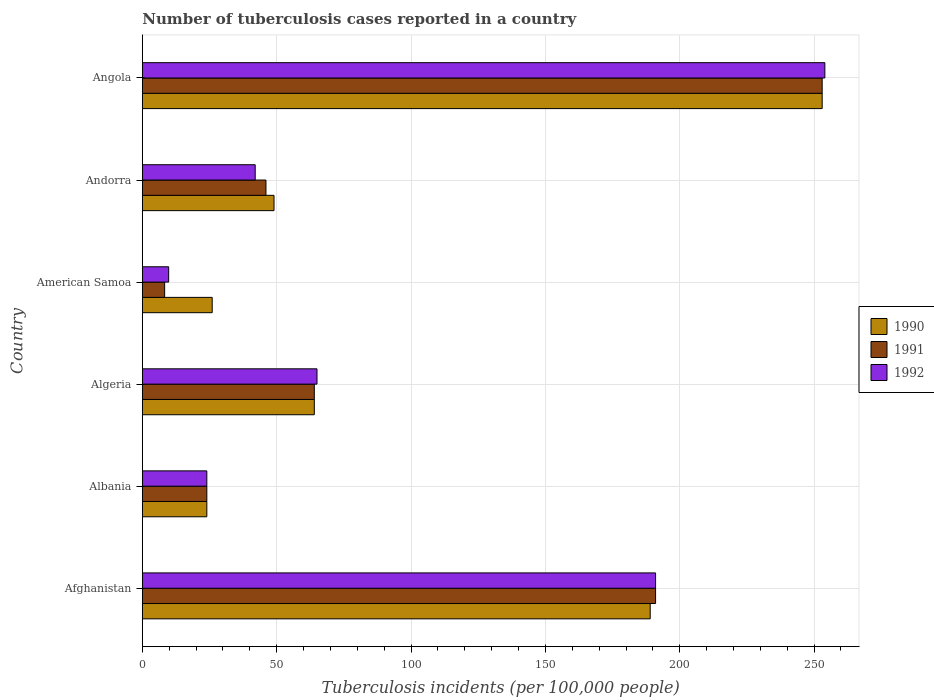How many different coloured bars are there?
Make the answer very short. 3. How many groups of bars are there?
Give a very brief answer. 6. Are the number of bars per tick equal to the number of legend labels?
Your answer should be compact. Yes. Are the number of bars on each tick of the Y-axis equal?
Keep it short and to the point. Yes. How many bars are there on the 2nd tick from the bottom?
Provide a succinct answer. 3. What is the label of the 5th group of bars from the top?
Keep it short and to the point. Albania. In how many cases, is the number of bars for a given country not equal to the number of legend labels?
Give a very brief answer. 0. What is the number of tuberculosis cases reported in in 1992 in Angola?
Give a very brief answer. 254. Across all countries, what is the maximum number of tuberculosis cases reported in in 1990?
Keep it short and to the point. 253. In which country was the number of tuberculosis cases reported in in 1990 maximum?
Ensure brevity in your answer.  Angola. In which country was the number of tuberculosis cases reported in in 1991 minimum?
Give a very brief answer. American Samoa. What is the total number of tuberculosis cases reported in in 1992 in the graph?
Offer a terse response. 585.8. What is the difference between the number of tuberculosis cases reported in in 1990 in Albania and the number of tuberculosis cases reported in in 1992 in Afghanistan?
Provide a short and direct response. -167. What is the average number of tuberculosis cases reported in in 1992 per country?
Make the answer very short. 97.63. What is the difference between the number of tuberculosis cases reported in in 1990 and number of tuberculosis cases reported in in 1992 in American Samoa?
Make the answer very short. 16.2. In how many countries, is the number of tuberculosis cases reported in in 1991 greater than 80 ?
Your answer should be very brief. 2. What is the ratio of the number of tuberculosis cases reported in in 1992 in Afghanistan to that in Albania?
Provide a short and direct response. 7.96. What is the difference between the highest and the lowest number of tuberculosis cases reported in in 1992?
Your response must be concise. 244.2. Is it the case that in every country, the sum of the number of tuberculosis cases reported in in 1992 and number of tuberculosis cases reported in in 1991 is greater than the number of tuberculosis cases reported in in 1990?
Your response must be concise. No. How many bars are there?
Ensure brevity in your answer.  18. How many countries are there in the graph?
Keep it short and to the point. 6. What is the difference between two consecutive major ticks on the X-axis?
Provide a succinct answer. 50. Where does the legend appear in the graph?
Give a very brief answer. Center right. What is the title of the graph?
Offer a terse response. Number of tuberculosis cases reported in a country. What is the label or title of the X-axis?
Your answer should be compact. Tuberculosis incidents (per 100,0 people). What is the Tuberculosis incidents (per 100,000 people) in 1990 in Afghanistan?
Ensure brevity in your answer.  189. What is the Tuberculosis incidents (per 100,000 people) of 1991 in Afghanistan?
Provide a short and direct response. 191. What is the Tuberculosis incidents (per 100,000 people) in 1992 in Afghanistan?
Offer a terse response. 191. What is the Tuberculosis incidents (per 100,000 people) in 1990 in Albania?
Your answer should be compact. 24. What is the Tuberculosis incidents (per 100,000 people) of 1991 in Albania?
Your response must be concise. 24. What is the Tuberculosis incidents (per 100,000 people) in 1992 in Algeria?
Your response must be concise. 65. What is the Tuberculosis incidents (per 100,000 people) in 1991 in Andorra?
Make the answer very short. 46. What is the Tuberculosis incidents (per 100,000 people) of 1992 in Andorra?
Keep it short and to the point. 42. What is the Tuberculosis incidents (per 100,000 people) in 1990 in Angola?
Offer a very short reply. 253. What is the Tuberculosis incidents (per 100,000 people) in 1991 in Angola?
Provide a succinct answer. 253. What is the Tuberculosis incidents (per 100,000 people) of 1992 in Angola?
Your answer should be very brief. 254. Across all countries, what is the maximum Tuberculosis incidents (per 100,000 people) in 1990?
Provide a succinct answer. 253. Across all countries, what is the maximum Tuberculosis incidents (per 100,000 people) in 1991?
Give a very brief answer. 253. Across all countries, what is the maximum Tuberculosis incidents (per 100,000 people) in 1992?
Offer a very short reply. 254. Across all countries, what is the minimum Tuberculosis incidents (per 100,000 people) of 1991?
Provide a succinct answer. 8.3. Across all countries, what is the minimum Tuberculosis incidents (per 100,000 people) of 1992?
Ensure brevity in your answer.  9.8. What is the total Tuberculosis incidents (per 100,000 people) in 1990 in the graph?
Your answer should be very brief. 605. What is the total Tuberculosis incidents (per 100,000 people) of 1991 in the graph?
Your response must be concise. 586.3. What is the total Tuberculosis incidents (per 100,000 people) of 1992 in the graph?
Provide a short and direct response. 585.8. What is the difference between the Tuberculosis incidents (per 100,000 people) of 1990 in Afghanistan and that in Albania?
Provide a short and direct response. 165. What is the difference between the Tuberculosis incidents (per 100,000 people) of 1991 in Afghanistan and that in Albania?
Give a very brief answer. 167. What is the difference between the Tuberculosis incidents (per 100,000 people) in 1992 in Afghanistan and that in Albania?
Offer a very short reply. 167. What is the difference between the Tuberculosis incidents (per 100,000 people) in 1990 in Afghanistan and that in Algeria?
Make the answer very short. 125. What is the difference between the Tuberculosis incidents (per 100,000 people) of 1991 in Afghanistan and that in Algeria?
Give a very brief answer. 127. What is the difference between the Tuberculosis incidents (per 100,000 people) in 1992 in Afghanistan and that in Algeria?
Your answer should be very brief. 126. What is the difference between the Tuberculosis incidents (per 100,000 people) of 1990 in Afghanistan and that in American Samoa?
Your answer should be very brief. 163. What is the difference between the Tuberculosis incidents (per 100,000 people) in 1991 in Afghanistan and that in American Samoa?
Provide a succinct answer. 182.7. What is the difference between the Tuberculosis incidents (per 100,000 people) of 1992 in Afghanistan and that in American Samoa?
Keep it short and to the point. 181.2. What is the difference between the Tuberculosis incidents (per 100,000 people) in 1990 in Afghanistan and that in Andorra?
Keep it short and to the point. 140. What is the difference between the Tuberculosis incidents (per 100,000 people) of 1991 in Afghanistan and that in Andorra?
Offer a very short reply. 145. What is the difference between the Tuberculosis incidents (per 100,000 people) of 1992 in Afghanistan and that in Andorra?
Your answer should be compact. 149. What is the difference between the Tuberculosis incidents (per 100,000 people) in 1990 in Afghanistan and that in Angola?
Your answer should be compact. -64. What is the difference between the Tuberculosis incidents (per 100,000 people) in 1991 in Afghanistan and that in Angola?
Keep it short and to the point. -62. What is the difference between the Tuberculosis incidents (per 100,000 people) of 1992 in Afghanistan and that in Angola?
Keep it short and to the point. -63. What is the difference between the Tuberculosis incidents (per 100,000 people) in 1992 in Albania and that in Algeria?
Your answer should be very brief. -41. What is the difference between the Tuberculosis incidents (per 100,000 people) in 1991 in Albania and that in American Samoa?
Offer a very short reply. 15.7. What is the difference between the Tuberculosis incidents (per 100,000 people) of 1992 in Albania and that in American Samoa?
Your answer should be very brief. 14.2. What is the difference between the Tuberculosis incidents (per 100,000 people) in 1990 in Albania and that in Andorra?
Give a very brief answer. -25. What is the difference between the Tuberculosis incidents (per 100,000 people) of 1992 in Albania and that in Andorra?
Your answer should be very brief. -18. What is the difference between the Tuberculosis incidents (per 100,000 people) in 1990 in Albania and that in Angola?
Your answer should be very brief. -229. What is the difference between the Tuberculosis incidents (per 100,000 people) in 1991 in Albania and that in Angola?
Your answer should be very brief. -229. What is the difference between the Tuberculosis incidents (per 100,000 people) of 1992 in Albania and that in Angola?
Your response must be concise. -230. What is the difference between the Tuberculosis incidents (per 100,000 people) of 1990 in Algeria and that in American Samoa?
Offer a very short reply. 38. What is the difference between the Tuberculosis incidents (per 100,000 people) in 1991 in Algeria and that in American Samoa?
Keep it short and to the point. 55.7. What is the difference between the Tuberculosis incidents (per 100,000 people) in 1992 in Algeria and that in American Samoa?
Give a very brief answer. 55.2. What is the difference between the Tuberculosis incidents (per 100,000 people) in 1991 in Algeria and that in Andorra?
Provide a succinct answer. 18. What is the difference between the Tuberculosis incidents (per 100,000 people) of 1990 in Algeria and that in Angola?
Your answer should be very brief. -189. What is the difference between the Tuberculosis incidents (per 100,000 people) of 1991 in Algeria and that in Angola?
Keep it short and to the point. -189. What is the difference between the Tuberculosis incidents (per 100,000 people) of 1992 in Algeria and that in Angola?
Keep it short and to the point. -189. What is the difference between the Tuberculosis incidents (per 100,000 people) of 1991 in American Samoa and that in Andorra?
Ensure brevity in your answer.  -37.7. What is the difference between the Tuberculosis incidents (per 100,000 people) of 1992 in American Samoa and that in Andorra?
Your answer should be very brief. -32.2. What is the difference between the Tuberculosis incidents (per 100,000 people) in 1990 in American Samoa and that in Angola?
Ensure brevity in your answer.  -227. What is the difference between the Tuberculosis incidents (per 100,000 people) of 1991 in American Samoa and that in Angola?
Give a very brief answer. -244.7. What is the difference between the Tuberculosis incidents (per 100,000 people) of 1992 in American Samoa and that in Angola?
Make the answer very short. -244.2. What is the difference between the Tuberculosis incidents (per 100,000 people) of 1990 in Andorra and that in Angola?
Your answer should be compact. -204. What is the difference between the Tuberculosis incidents (per 100,000 people) in 1991 in Andorra and that in Angola?
Ensure brevity in your answer.  -207. What is the difference between the Tuberculosis incidents (per 100,000 people) of 1992 in Andorra and that in Angola?
Ensure brevity in your answer.  -212. What is the difference between the Tuberculosis incidents (per 100,000 people) of 1990 in Afghanistan and the Tuberculosis incidents (per 100,000 people) of 1991 in Albania?
Provide a short and direct response. 165. What is the difference between the Tuberculosis incidents (per 100,000 people) of 1990 in Afghanistan and the Tuberculosis incidents (per 100,000 people) of 1992 in Albania?
Provide a short and direct response. 165. What is the difference between the Tuberculosis incidents (per 100,000 people) of 1991 in Afghanistan and the Tuberculosis incidents (per 100,000 people) of 1992 in Albania?
Your answer should be very brief. 167. What is the difference between the Tuberculosis incidents (per 100,000 people) in 1990 in Afghanistan and the Tuberculosis incidents (per 100,000 people) in 1991 in Algeria?
Ensure brevity in your answer.  125. What is the difference between the Tuberculosis incidents (per 100,000 people) of 1990 in Afghanistan and the Tuberculosis incidents (per 100,000 people) of 1992 in Algeria?
Provide a succinct answer. 124. What is the difference between the Tuberculosis incidents (per 100,000 people) in 1991 in Afghanistan and the Tuberculosis incidents (per 100,000 people) in 1992 in Algeria?
Your answer should be compact. 126. What is the difference between the Tuberculosis incidents (per 100,000 people) of 1990 in Afghanistan and the Tuberculosis incidents (per 100,000 people) of 1991 in American Samoa?
Keep it short and to the point. 180.7. What is the difference between the Tuberculosis incidents (per 100,000 people) in 1990 in Afghanistan and the Tuberculosis incidents (per 100,000 people) in 1992 in American Samoa?
Your answer should be compact. 179.2. What is the difference between the Tuberculosis incidents (per 100,000 people) of 1991 in Afghanistan and the Tuberculosis incidents (per 100,000 people) of 1992 in American Samoa?
Offer a very short reply. 181.2. What is the difference between the Tuberculosis incidents (per 100,000 people) in 1990 in Afghanistan and the Tuberculosis incidents (per 100,000 people) in 1991 in Andorra?
Make the answer very short. 143. What is the difference between the Tuberculosis incidents (per 100,000 people) of 1990 in Afghanistan and the Tuberculosis incidents (per 100,000 people) of 1992 in Andorra?
Your response must be concise. 147. What is the difference between the Tuberculosis incidents (per 100,000 people) in 1991 in Afghanistan and the Tuberculosis incidents (per 100,000 people) in 1992 in Andorra?
Ensure brevity in your answer.  149. What is the difference between the Tuberculosis incidents (per 100,000 people) in 1990 in Afghanistan and the Tuberculosis incidents (per 100,000 people) in 1991 in Angola?
Provide a short and direct response. -64. What is the difference between the Tuberculosis incidents (per 100,000 people) of 1990 in Afghanistan and the Tuberculosis incidents (per 100,000 people) of 1992 in Angola?
Keep it short and to the point. -65. What is the difference between the Tuberculosis incidents (per 100,000 people) of 1991 in Afghanistan and the Tuberculosis incidents (per 100,000 people) of 1992 in Angola?
Provide a succinct answer. -63. What is the difference between the Tuberculosis incidents (per 100,000 people) in 1990 in Albania and the Tuberculosis incidents (per 100,000 people) in 1992 in Algeria?
Keep it short and to the point. -41. What is the difference between the Tuberculosis incidents (per 100,000 people) in 1991 in Albania and the Tuberculosis incidents (per 100,000 people) in 1992 in Algeria?
Keep it short and to the point. -41. What is the difference between the Tuberculosis incidents (per 100,000 people) of 1990 in Albania and the Tuberculosis incidents (per 100,000 people) of 1991 in American Samoa?
Your answer should be compact. 15.7. What is the difference between the Tuberculosis incidents (per 100,000 people) in 1990 in Albania and the Tuberculosis incidents (per 100,000 people) in 1992 in American Samoa?
Offer a terse response. 14.2. What is the difference between the Tuberculosis incidents (per 100,000 people) in 1991 in Albania and the Tuberculosis incidents (per 100,000 people) in 1992 in American Samoa?
Provide a succinct answer. 14.2. What is the difference between the Tuberculosis incidents (per 100,000 people) of 1990 in Albania and the Tuberculosis incidents (per 100,000 people) of 1991 in Andorra?
Your answer should be compact. -22. What is the difference between the Tuberculosis incidents (per 100,000 people) in 1990 in Albania and the Tuberculosis incidents (per 100,000 people) in 1992 in Andorra?
Ensure brevity in your answer.  -18. What is the difference between the Tuberculosis incidents (per 100,000 people) of 1990 in Albania and the Tuberculosis incidents (per 100,000 people) of 1991 in Angola?
Ensure brevity in your answer.  -229. What is the difference between the Tuberculosis incidents (per 100,000 people) of 1990 in Albania and the Tuberculosis incidents (per 100,000 people) of 1992 in Angola?
Offer a very short reply. -230. What is the difference between the Tuberculosis incidents (per 100,000 people) in 1991 in Albania and the Tuberculosis incidents (per 100,000 people) in 1992 in Angola?
Provide a short and direct response. -230. What is the difference between the Tuberculosis incidents (per 100,000 people) of 1990 in Algeria and the Tuberculosis incidents (per 100,000 people) of 1991 in American Samoa?
Give a very brief answer. 55.7. What is the difference between the Tuberculosis incidents (per 100,000 people) in 1990 in Algeria and the Tuberculosis incidents (per 100,000 people) in 1992 in American Samoa?
Your response must be concise. 54.2. What is the difference between the Tuberculosis incidents (per 100,000 people) in 1991 in Algeria and the Tuberculosis incidents (per 100,000 people) in 1992 in American Samoa?
Give a very brief answer. 54.2. What is the difference between the Tuberculosis incidents (per 100,000 people) of 1990 in Algeria and the Tuberculosis incidents (per 100,000 people) of 1992 in Andorra?
Provide a short and direct response. 22. What is the difference between the Tuberculosis incidents (per 100,000 people) in 1991 in Algeria and the Tuberculosis incidents (per 100,000 people) in 1992 in Andorra?
Provide a succinct answer. 22. What is the difference between the Tuberculosis incidents (per 100,000 people) in 1990 in Algeria and the Tuberculosis incidents (per 100,000 people) in 1991 in Angola?
Ensure brevity in your answer.  -189. What is the difference between the Tuberculosis incidents (per 100,000 people) of 1990 in Algeria and the Tuberculosis incidents (per 100,000 people) of 1992 in Angola?
Your response must be concise. -190. What is the difference between the Tuberculosis incidents (per 100,000 people) in 1991 in Algeria and the Tuberculosis incidents (per 100,000 people) in 1992 in Angola?
Ensure brevity in your answer.  -190. What is the difference between the Tuberculosis incidents (per 100,000 people) of 1991 in American Samoa and the Tuberculosis incidents (per 100,000 people) of 1992 in Andorra?
Offer a very short reply. -33.7. What is the difference between the Tuberculosis incidents (per 100,000 people) of 1990 in American Samoa and the Tuberculosis incidents (per 100,000 people) of 1991 in Angola?
Your answer should be compact. -227. What is the difference between the Tuberculosis incidents (per 100,000 people) in 1990 in American Samoa and the Tuberculosis incidents (per 100,000 people) in 1992 in Angola?
Offer a very short reply. -228. What is the difference between the Tuberculosis incidents (per 100,000 people) in 1991 in American Samoa and the Tuberculosis incidents (per 100,000 people) in 1992 in Angola?
Your answer should be very brief. -245.7. What is the difference between the Tuberculosis incidents (per 100,000 people) in 1990 in Andorra and the Tuberculosis incidents (per 100,000 people) in 1991 in Angola?
Keep it short and to the point. -204. What is the difference between the Tuberculosis incidents (per 100,000 people) of 1990 in Andorra and the Tuberculosis incidents (per 100,000 people) of 1992 in Angola?
Your answer should be very brief. -205. What is the difference between the Tuberculosis incidents (per 100,000 people) of 1991 in Andorra and the Tuberculosis incidents (per 100,000 people) of 1992 in Angola?
Your response must be concise. -208. What is the average Tuberculosis incidents (per 100,000 people) of 1990 per country?
Make the answer very short. 100.83. What is the average Tuberculosis incidents (per 100,000 people) of 1991 per country?
Make the answer very short. 97.72. What is the average Tuberculosis incidents (per 100,000 people) in 1992 per country?
Provide a short and direct response. 97.63. What is the difference between the Tuberculosis incidents (per 100,000 people) of 1990 and Tuberculosis incidents (per 100,000 people) of 1992 in Afghanistan?
Give a very brief answer. -2. What is the difference between the Tuberculosis incidents (per 100,000 people) of 1990 and Tuberculosis incidents (per 100,000 people) of 1991 in Albania?
Your answer should be very brief. 0. What is the difference between the Tuberculosis incidents (per 100,000 people) in 1990 and Tuberculosis incidents (per 100,000 people) in 1992 in Albania?
Keep it short and to the point. 0. What is the difference between the Tuberculosis incidents (per 100,000 people) in 1990 and Tuberculosis incidents (per 100,000 people) in 1992 in Algeria?
Your answer should be compact. -1. What is the difference between the Tuberculosis incidents (per 100,000 people) in 1990 and Tuberculosis incidents (per 100,000 people) in 1991 in American Samoa?
Make the answer very short. 17.7. What is the difference between the Tuberculosis incidents (per 100,000 people) in 1991 and Tuberculosis incidents (per 100,000 people) in 1992 in American Samoa?
Keep it short and to the point. -1.5. What is the ratio of the Tuberculosis incidents (per 100,000 people) of 1990 in Afghanistan to that in Albania?
Offer a very short reply. 7.88. What is the ratio of the Tuberculosis incidents (per 100,000 people) of 1991 in Afghanistan to that in Albania?
Your answer should be very brief. 7.96. What is the ratio of the Tuberculosis incidents (per 100,000 people) in 1992 in Afghanistan to that in Albania?
Provide a short and direct response. 7.96. What is the ratio of the Tuberculosis incidents (per 100,000 people) in 1990 in Afghanistan to that in Algeria?
Ensure brevity in your answer.  2.95. What is the ratio of the Tuberculosis incidents (per 100,000 people) in 1991 in Afghanistan to that in Algeria?
Offer a very short reply. 2.98. What is the ratio of the Tuberculosis incidents (per 100,000 people) in 1992 in Afghanistan to that in Algeria?
Your answer should be compact. 2.94. What is the ratio of the Tuberculosis incidents (per 100,000 people) in 1990 in Afghanistan to that in American Samoa?
Provide a short and direct response. 7.27. What is the ratio of the Tuberculosis incidents (per 100,000 people) in 1991 in Afghanistan to that in American Samoa?
Offer a terse response. 23.01. What is the ratio of the Tuberculosis incidents (per 100,000 people) of 1992 in Afghanistan to that in American Samoa?
Your answer should be very brief. 19.49. What is the ratio of the Tuberculosis incidents (per 100,000 people) in 1990 in Afghanistan to that in Andorra?
Keep it short and to the point. 3.86. What is the ratio of the Tuberculosis incidents (per 100,000 people) of 1991 in Afghanistan to that in Andorra?
Your answer should be compact. 4.15. What is the ratio of the Tuberculosis incidents (per 100,000 people) of 1992 in Afghanistan to that in Andorra?
Ensure brevity in your answer.  4.55. What is the ratio of the Tuberculosis incidents (per 100,000 people) in 1990 in Afghanistan to that in Angola?
Make the answer very short. 0.75. What is the ratio of the Tuberculosis incidents (per 100,000 people) in 1991 in Afghanistan to that in Angola?
Provide a succinct answer. 0.75. What is the ratio of the Tuberculosis incidents (per 100,000 people) of 1992 in Afghanistan to that in Angola?
Your answer should be compact. 0.75. What is the ratio of the Tuberculosis incidents (per 100,000 people) of 1992 in Albania to that in Algeria?
Provide a succinct answer. 0.37. What is the ratio of the Tuberculosis incidents (per 100,000 people) of 1991 in Albania to that in American Samoa?
Give a very brief answer. 2.89. What is the ratio of the Tuberculosis incidents (per 100,000 people) in 1992 in Albania to that in American Samoa?
Provide a short and direct response. 2.45. What is the ratio of the Tuberculosis incidents (per 100,000 people) of 1990 in Albania to that in Andorra?
Make the answer very short. 0.49. What is the ratio of the Tuberculosis incidents (per 100,000 people) of 1991 in Albania to that in Andorra?
Offer a very short reply. 0.52. What is the ratio of the Tuberculosis incidents (per 100,000 people) in 1990 in Albania to that in Angola?
Your answer should be very brief. 0.09. What is the ratio of the Tuberculosis incidents (per 100,000 people) in 1991 in Albania to that in Angola?
Give a very brief answer. 0.09. What is the ratio of the Tuberculosis incidents (per 100,000 people) in 1992 in Albania to that in Angola?
Offer a very short reply. 0.09. What is the ratio of the Tuberculosis incidents (per 100,000 people) in 1990 in Algeria to that in American Samoa?
Make the answer very short. 2.46. What is the ratio of the Tuberculosis incidents (per 100,000 people) of 1991 in Algeria to that in American Samoa?
Offer a very short reply. 7.71. What is the ratio of the Tuberculosis incidents (per 100,000 people) of 1992 in Algeria to that in American Samoa?
Ensure brevity in your answer.  6.63. What is the ratio of the Tuberculosis incidents (per 100,000 people) of 1990 in Algeria to that in Andorra?
Ensure brevity in your answer.  1.31. What is the ratio of the Tuberculosis incidents (per 100,000 people) in 1991 in Algeria to that in Andorra?
Your answer should be very brief. 1.39. What is the ratio of the Tuberculosis incidents (per 100,000 people) in 1992 in Algeria to that in Andorra?
Give a very brief answer. 1.55. What is the ratio of the Tuberculosis incidents (per 100,000 people) of 1990 in Algeria to that in Angola?
Offer a very short reply. 0.25. What is the ratio of the Tuberculosis incidents (per 100,000 people) in 1991 in Algeria to that in Angola?
Provide a succinct answer. 0.25. What is the ratio of the Tuberculosis incidents (per 100,000 people) in 1992 in Algeria to that in Angola?
Ensure brevity in your answer.  0.26. What is the ratio of the Tuberculosis incidents (per 100,000 people) of 1990 in American Samoa to that in Andorra?
Make the answer very short. 0.53. What is the ratio of the Tuberculosis incidents (per 100,000 people) in 1991 in American Samoa to that in Andorra?
Give a very brief answer. 0.18. What is the ratio of the Tuberculosis incidents (per 100,000 people) of 1992 in American Samoa to that in Andorra?
Provide a short and direct response. 0.23. What is the ratio of the Tuberculosis incidents (per 100,000 people) of 1990 in American Samoa to that in Angola?
Keep it short and to the point. 0.1. What is the ratio of the Tuberculosis incidents (per 100,000 people) in 1991 in American Samoa to that in Angola?
Make the answer very short. 0.03. What is the ratio of the Tuberculosis incidents (per 100,000 people) of 1992 in American Samoa to that in Angola?
Provide a succinct answer. 0.04. What is the ratio of the Tuberculosis incidents (per 100,000 people) of 1990 in Andorra to that in Angola?
Ensure brevity in your answer.  0.19. What is the ratio of the Tuberculosis incidents (per 100,000 people) of 1991 in Andorra to that in Angola?
Your response must be concise. 0.18. What is the ratio of the Tuberculosis incidents (per 100,000 people) of 1992 in Andorra to that in Angola?
Provide a succinct answer. 0.17. What is the difference between the highest and the second highest Tuberculosis incidents (per 100,000 people) of 1992?
Your response must be concise. 63. What is the difference between the highest and the lowest Tuberculosis incidents (per 100,000 people) in 1990?
Make the answer very short. 229. What is the difference between the highest and the lowest Tuberculosis incidents (per 100,000 people) in 1991?
Give a very brief answer. 244.7. What is the difference between the highest and the lowest Tuberculosis incidents (per 100,000 people) in 1992?
Offer a very short reply. 244.2. 